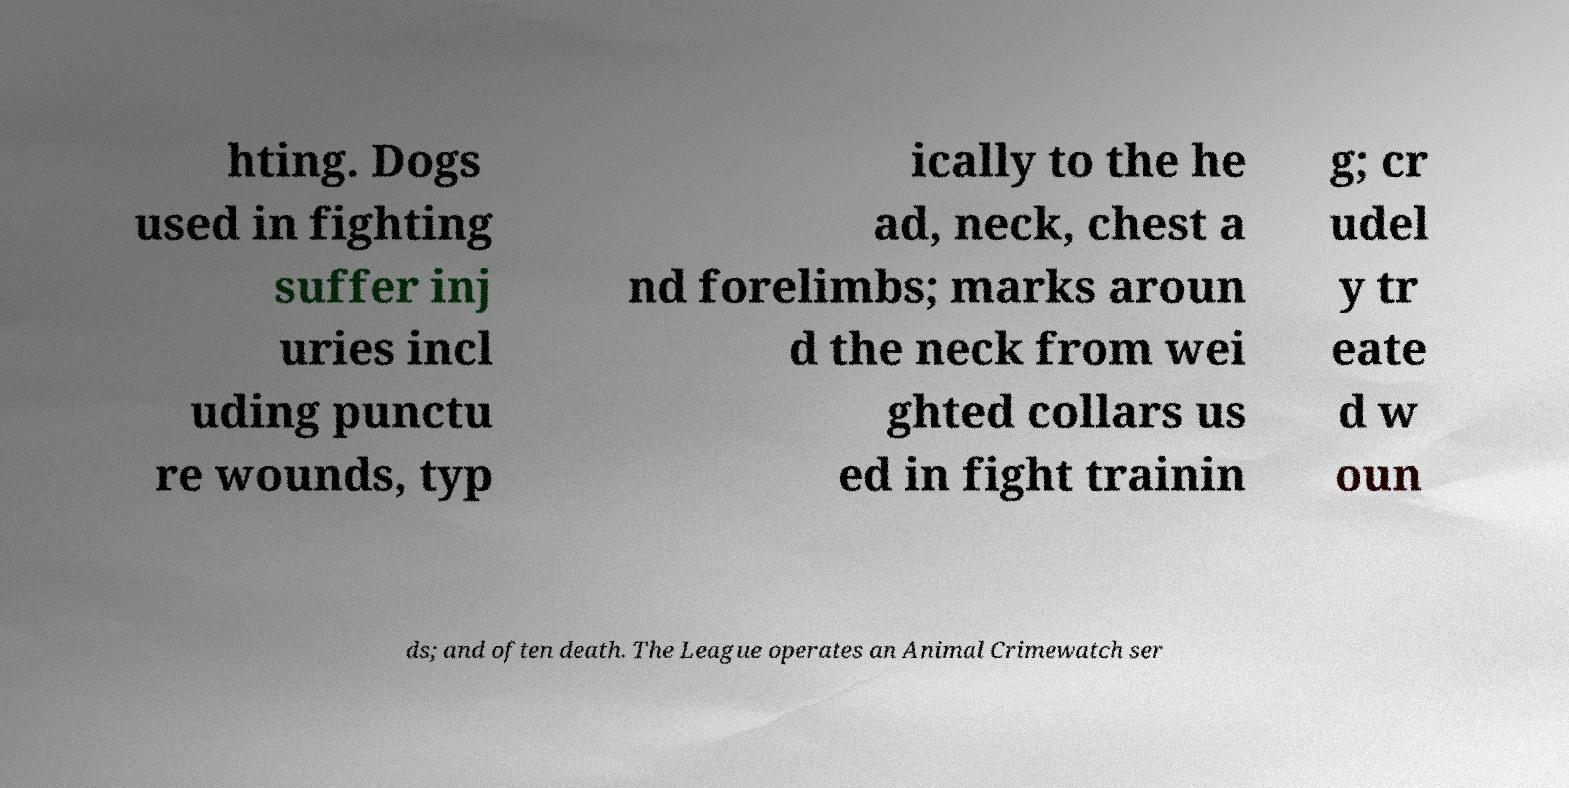What messages or text are displayed in this image? I need them in a readable, typed format. hting. Dogs used in fighting suffer inj uries incl uding punctu re wounds, typ ically to the he ad, neck, chest a nd forelimbs; marks aroun d the neck from wei ghted collars us ed in fight trainin g; cr udel y tr eate d w oun ds; and often death. The League operates an Animal Crimewatch ser 